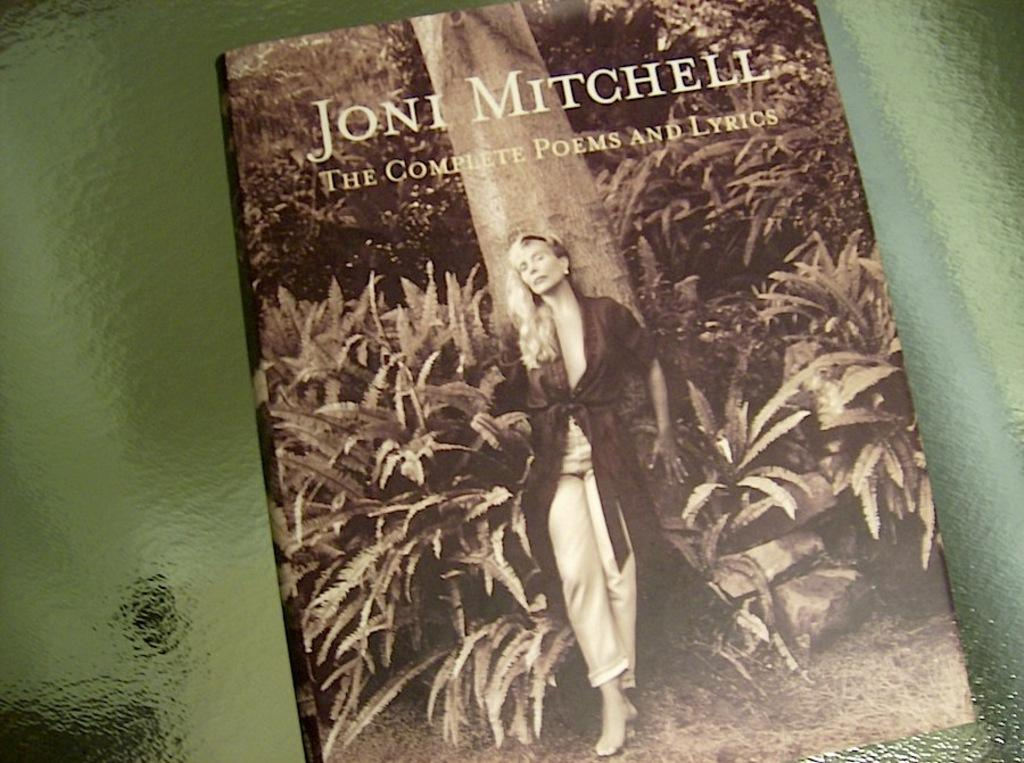Provide a one-sentence caption for the provided image. Joni Mitchell wrote a book called The Complete Poems and Lyrics. 